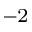Convert formula to latex. <formula><loc_0><loc_0><loc_500><loc_500>^ { - 2 }</formula> 